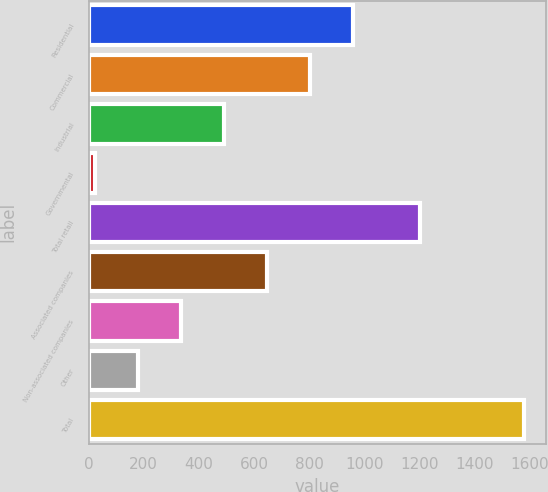Convert chart to OTSL. <chart><loc_0><loc_0><loc_500><loc_500><bar_chart><fcel>Residential<fcel>Commercial<fcel>Industrial<fcel>Governmental<fcel>Total retail<fcel>Associated companies<fcel>Non-associated companies<fcel>Other<fcel>Total<nl><fcel>958.2<fcel>802.5<fcel>491.1<fcel>24<fcel>1201<fcel>646.8<fcel>335.4<fcel>179.7<fcel>1581<nl></chart> 